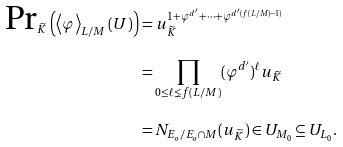<formula> <loc_0><loc_0><loc_500><loc_500>\text {Pr} _ { \widetilde { K } } \left ( \left < \varphi \right > _ { L / M } ( U ) \right ) & = u _ { \widetilde { K } } ^ { 1 + \varphi ^ { d ^ { \prime } } + \cdots + \varphi ^ { d ^ { \prime } ( f ( L / M ) - 1 ) } } \\ & = \prod _ { 0 \leq \ell \lneq f ( L / M ) } ( \varphi ^ { d ^ { \prime } } ) ^ { \ell } u _ { \widetilde { K } } \\ & = N _ { E _ { o } / E _ { o } \cap M } ( u _ { \widetilde { K } } ) \in U _ { M _ { 0 } } \subseteq U _ { L _ { 0 } } .</formula> 